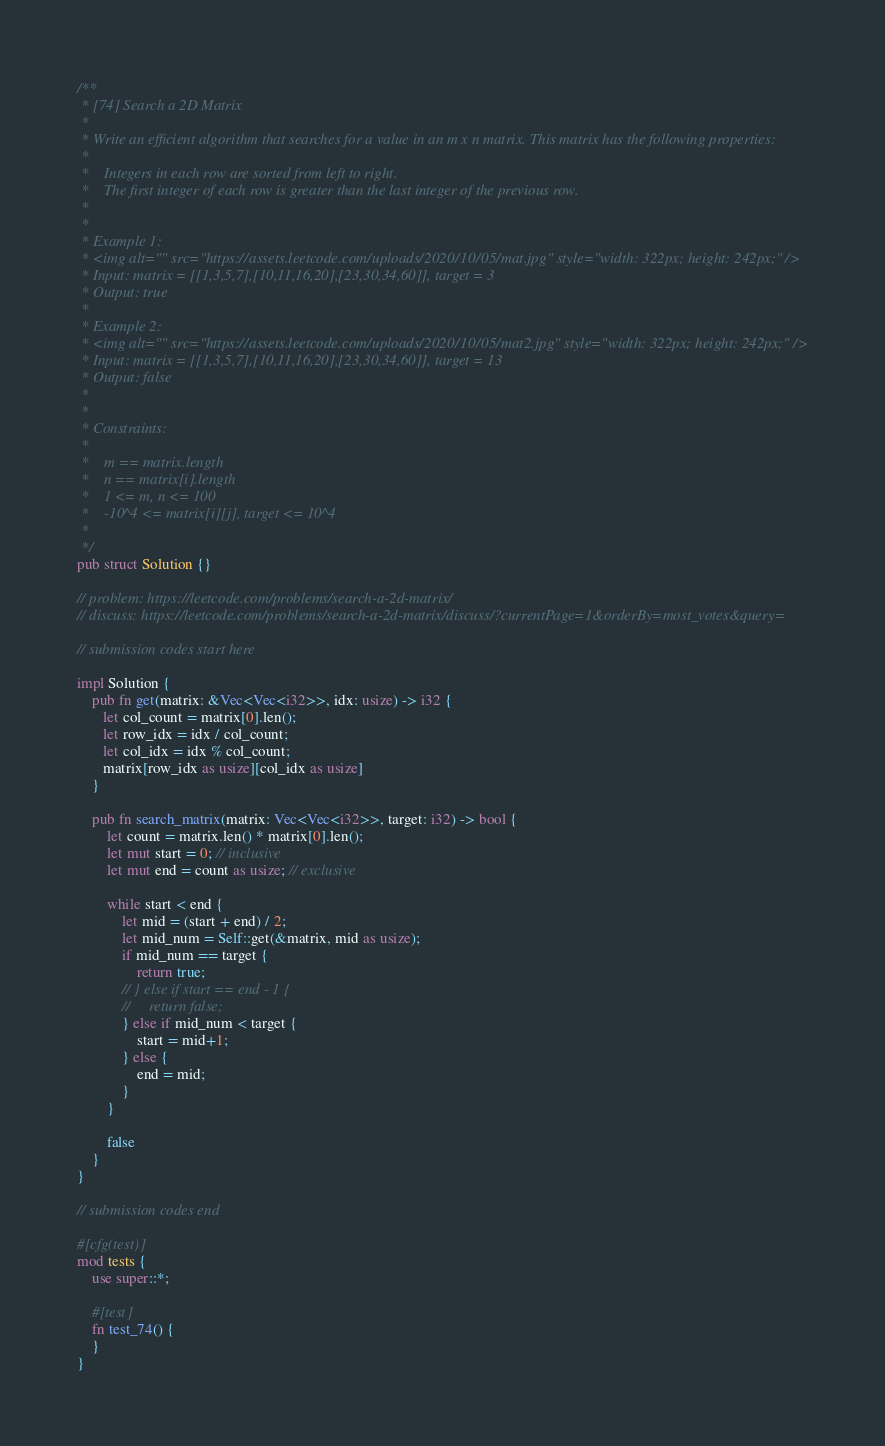Convert code to text. <code><loc_0><loc_0><loc_500><loc_500><_Rust_>/**
 * [74] Search a 2D Matrix
 *
 * Write an efficient algorithm that searches for a value in an m x n matrix. This matrix has the following properties:
 * 
 * 	Integers in each row are sorted from left to right.
 * 	The first integer of each row is greater than the last integer of the previous row.
 * 
 *  
 * Example 1:
 * <img alt="" src="https://assets.leetcode.com/uploads/2020/10/05/mat.jpg" style="width: 322px; height: 242px;" />
 * Input: matrix = [[1,3,5,7],[10,11,16,20],[23,30,34,60]], target = 3
 * Output: true
 * 
 * Example 2:
 * <img alt="" src="https://assets.leetcode.com/uploads/2020/10/05/mat2.jpg" style="width: 322px; height: 242px;" />
 * Input: matrix = [[1,3,5,7],[10,11,16,20],[23,30,34,60]], target = 13
 * Output: false
 * 
 *  
 * Constraints:
 * 
 * 	m == matrix.length
 * 	n == matrix[i].length
 * 	1 <= m, n <= 100
 * 	-10^4 <= matrix[i][j], target <= 10^4
 * 
 */
pub struct Solution {}

// problem: https://leetcode.com/problems/search-a-2d-matrix/
// discuss: https://leetcode.com/problems/search-a-2d-matrix/discuss/?currentPage=1&orderBy=most_votes&query=

// submission codes start here

impl Solution {
    pub fn get(matrix: &Vec<Vec<i32>>, idx: usize) -> i32 {
       let col_count = matrix[0].len(); 
       let row_idx = idx / col_count;
       let col_idx = idx % col_count;
       matrix[row_idx as usize][col_idx as usize]
    }

    pub fn search_matrix(matrix: Vec<Vec<i32>>, target: i32) -> bool {
        let count = matrix.len() * matrix[0].len();
        let mut start = 0; // inclusive
        let mut end = count as usize; // exclusive

        while start < end {
            let mid = (start + end) / 2;
            let mid_num = Self::get(&matrix, mid as usize);
            if mid_num == target {
                return true;
            // } else if start == end - 1 {
            //     return false;
            } else if mid_num < target {
                start = mid+1;
            } else {
                end = mid;
            }
        }

        false
    }
}

// submission codes end

#[cfg(test)]
mod tests {
    use super::*;

    #[test]
    fn test_74() {
    }
}
</code> 